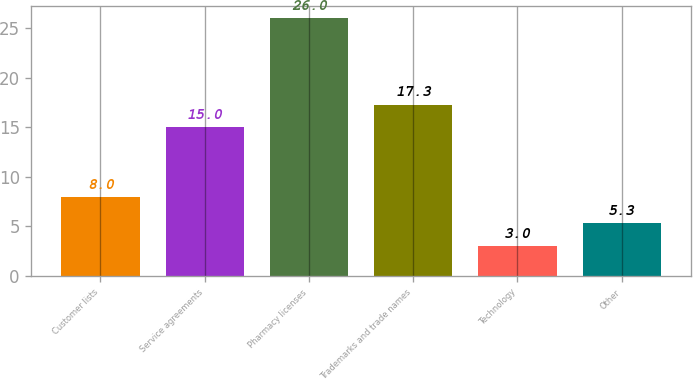Convert chart. <chart><loc_0><loc_0><loc_500><loc_500><bar_chart><fcel>Customer lists<fcel>Service agreements<fcel>Pharmacy licenses<fcel>Trademarks and trade names<fcel>Technology<fcel>Other<nl><fcel>8<fcel>15<fcel>26<fcel>17.3<fcel>3<fcel>5.3<nl></chart> 